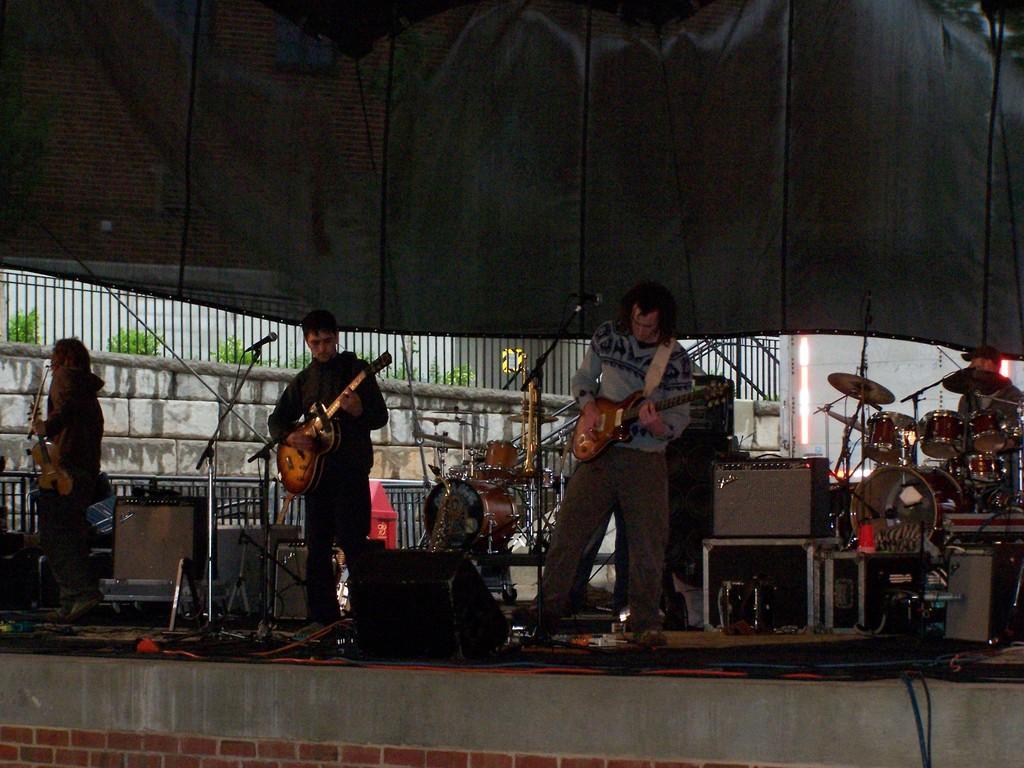Please provide a concise description of this image. Here we can see three persons are playing guitar. These are the mikes and there are some musical instruments. This is floor. There is a wall and these are the plants. Here we can see fence. 